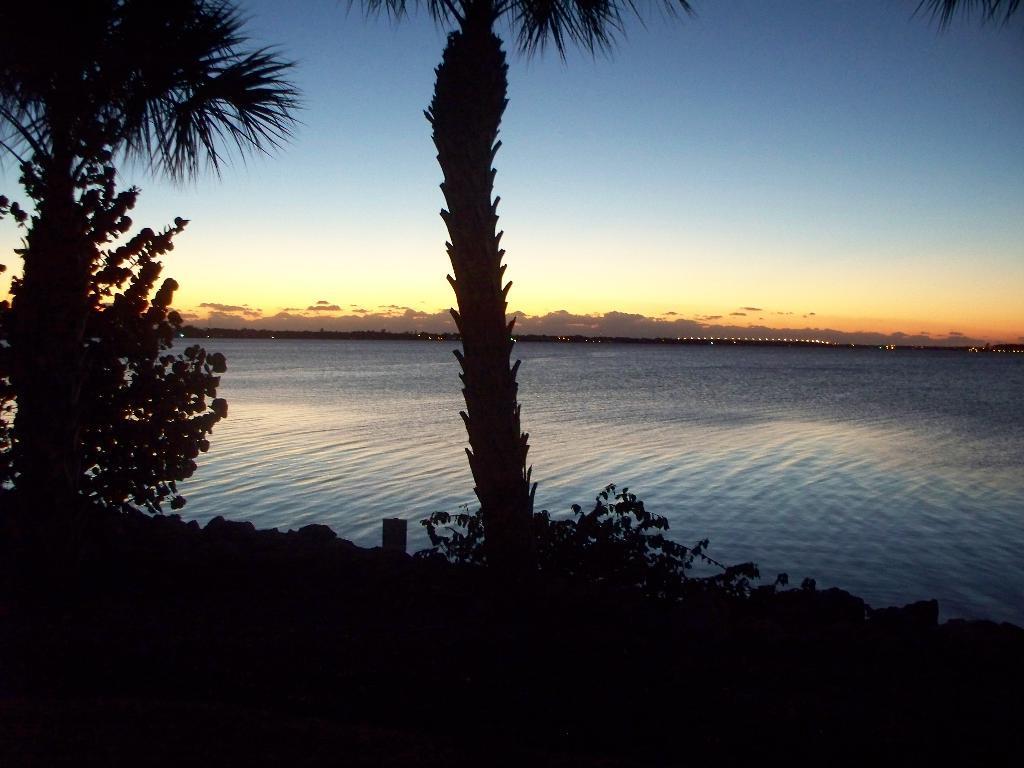In one or two sentences, can you explain what this image depicts? In the center of the image there are trees. There is water. In the background of the image there is sky. 